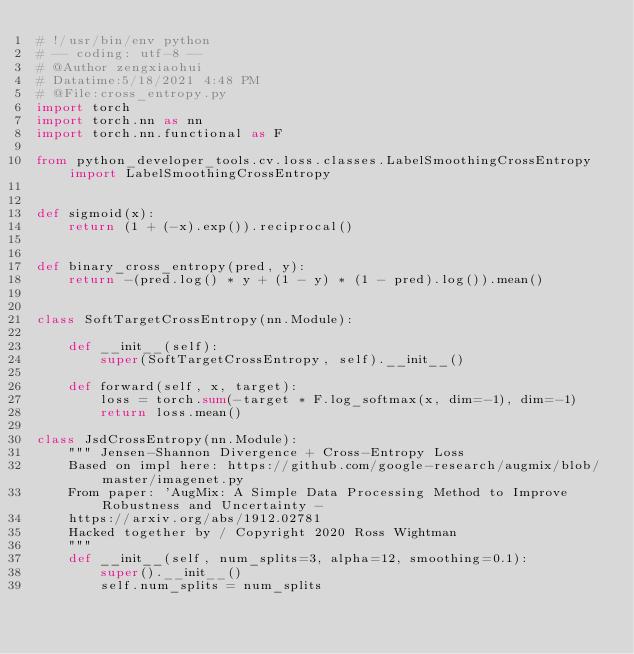Convert code to text. <code><loc_0><loc_0><loc_500><loc_500><_Python_># !/usr/bin/env python
# -- coding: utf-8 --
# @Author zengxiaohui
# Datatime:5/18/2021 4:48 PM
# @File:cross_entropy.py
import torch
import torch.nn as nn
import torch.nn.functional as F

from python_developer_tools.cv.loss.classes.LabelSmoothingCrossEntropy import LabelSmoothingCrossEntropy


def sigmoid(x):
    return (1 + (-x).exp()).reciprocal()


def binary_cross_entropy(pred, y):
    return -(pred.log() * y + (1 - y) * (1 - pred).log()).mean()


class SoftTargetCrossEntropy(nn.Module):

    def __init__(self):
        super(SoftTargetCrossEntropy, self).__init__()

    def forward(self, x, target):
        loss = torch.sum(-target * F.log_softmax(x, dim=-1), dim=-1)
        return loss.mean()

class JsdCrossEntropy(nn.Module):
    """ Jensen-Shannon Divergence + Cross-Entropy Loss
    Based on impl here: https://github.com/google-research/augmix/blob/master/imagenet.py
    From paper: 'AugMix: A Simple Data Processing Method to Improve Robustness and Uncertainty -
    https://arxiv.org/abs/1912.02781
    Hacked together by / Copyright 2020 Ross Wightman
    """
    def __init__(self, num_splits=3, alpha=12, smoothing=0.1):
        super().__init__()
        self.num_splits = num_splits</code> 